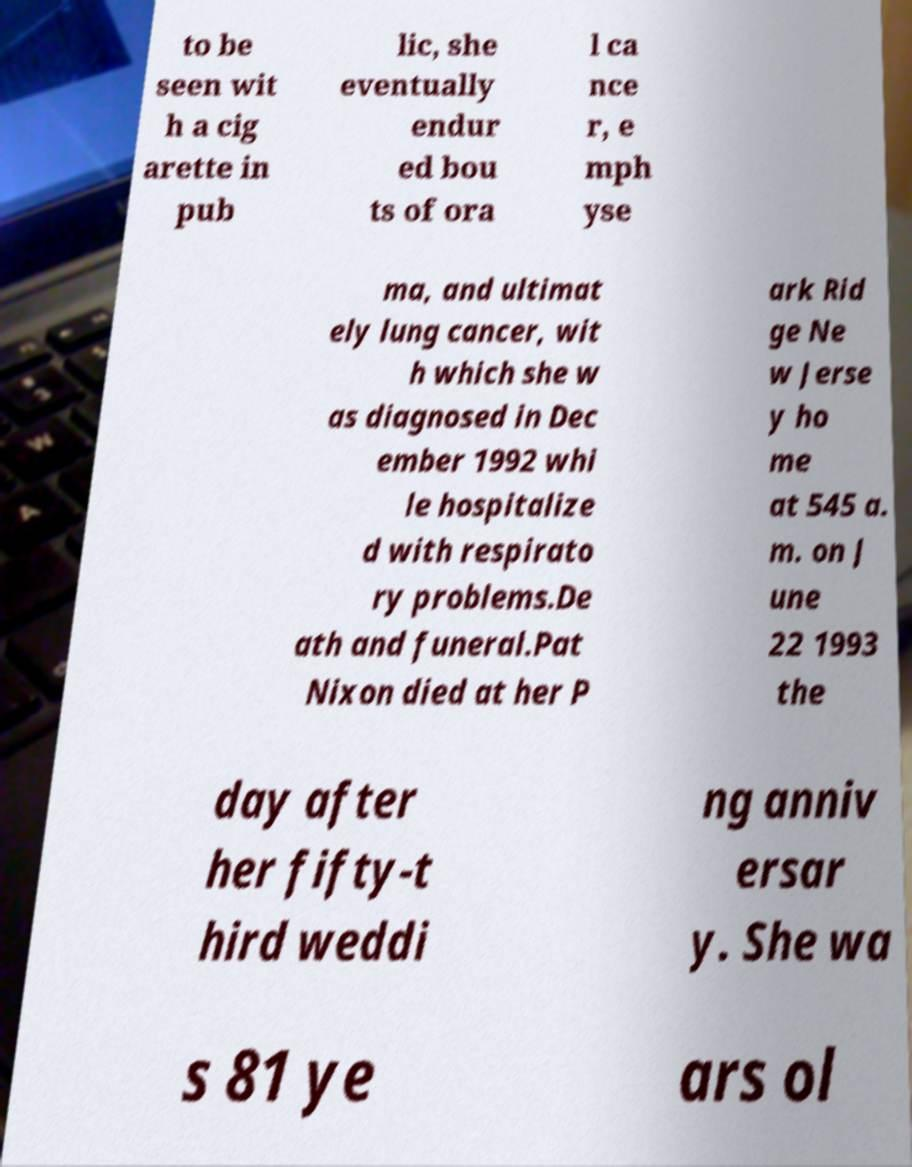Could you assist in decoding the text presented in this image and type it out clearly? to be seen wit h a cig arette in pub lic, she eventually endur ed bou ts of ora l ca nce r, e mph yse ma, and ultimat ely lung cancer, wit h which she w as diagnosed in Dec ember 1992 whi le hospitalize d with respirato ry problems.De ath and funeral.Pat Nixon died at her P ark Rid ge Ne w Jerse y ho me at 545 a. m. on J une 22 1993 the day after her fifty-t hird weddi ng anniv ersar y. She wa s 81 ye ars ol 